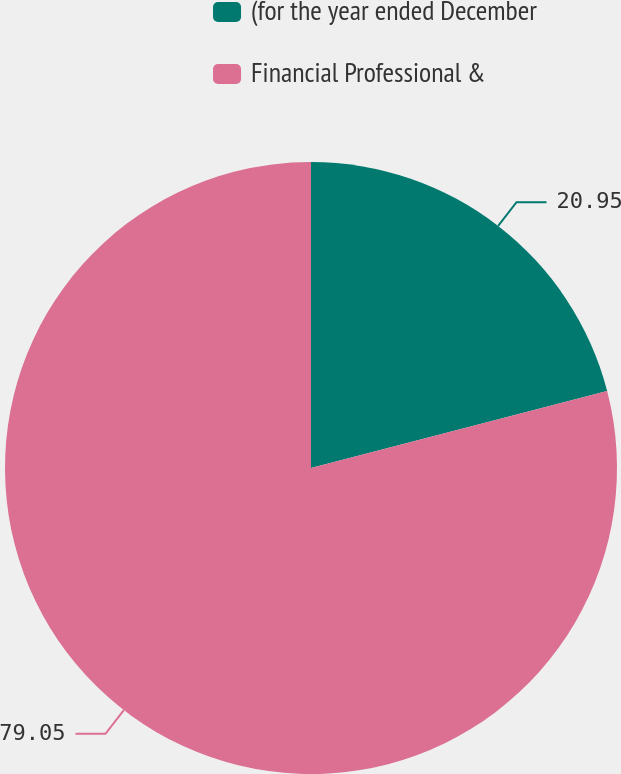<chart> <loc_0><loc_0><loc_500><loc_500><pie_chart><fcel>(for the year ended December<fcel>Financial Professional &<nl><fcel>20.95%<fcel>79.05%<nl></chart> 